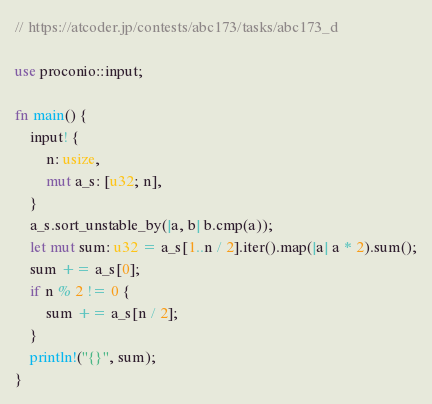Convert code to text. <code><loc_0><loc_0><loc_500><loc_500><_Rust_>// https://atcoder.jp/contests/abc173/tasks/abc173_d

use proconio::input;

fn main() {
    input! {
        n: usize,
        mut a_s: [u32; n],
    }
    a_s.sort_unstable_by(|a, b| b.cmp(a));
    let mut sum: u32 = a_s[1..n / 2].iter().map(|a| a * 2).sum();
    sum += a_s[0];
    if n % 2 != 0 {
        sum += a_s[n / 2];
    }
    println!("{}", sum);
}
</code> 